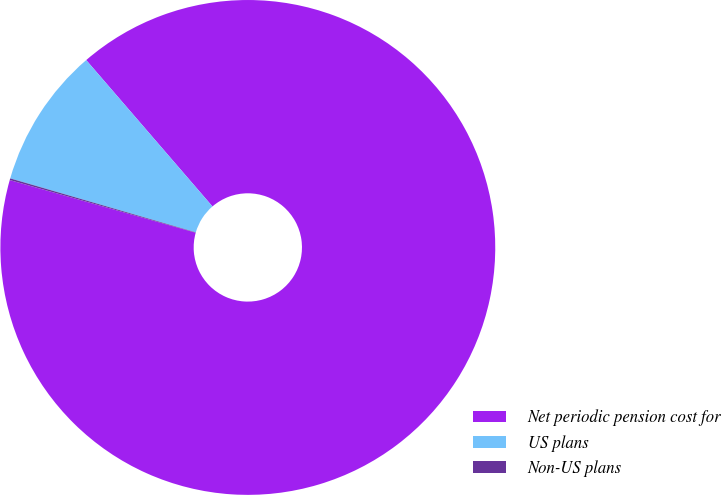Convert chart to OTSL. <chart><loc_0><loc_0><loc_500><loc_500><pie_chart><fcel>Net periodic pension cost for<fcel>US plans<fcel>Non-US plans<nl><fcel>90.71%<fcel>9.17%<fcel>0.11%<nl></chart> 